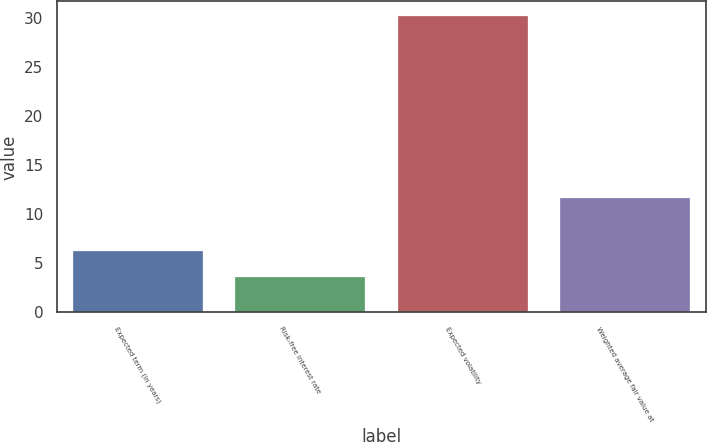Convert chart to OTSL. <chart><loc_0><loc_0><loc_500><loc_500><bar_chart><fcel>Expected term (in years)<fcel>Risk-free interest rate<fcel>Expected volatility<fcel>Weighted average fair value at<nl><fcel>6.26<fcel>3.6<fcel>30.2<fcel>11.62<nl></chart> 